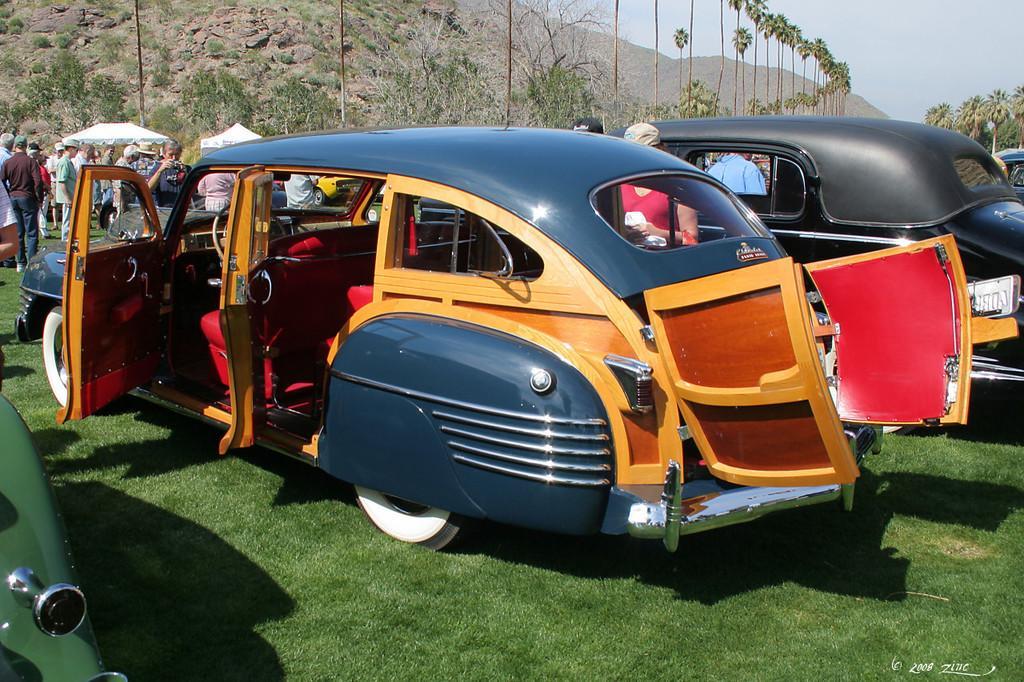Please provide a concise description of this image. In this image I can see the grass. I can see the vehicles. I can see some people. In the background, I can see the hills, trees and the sky. 